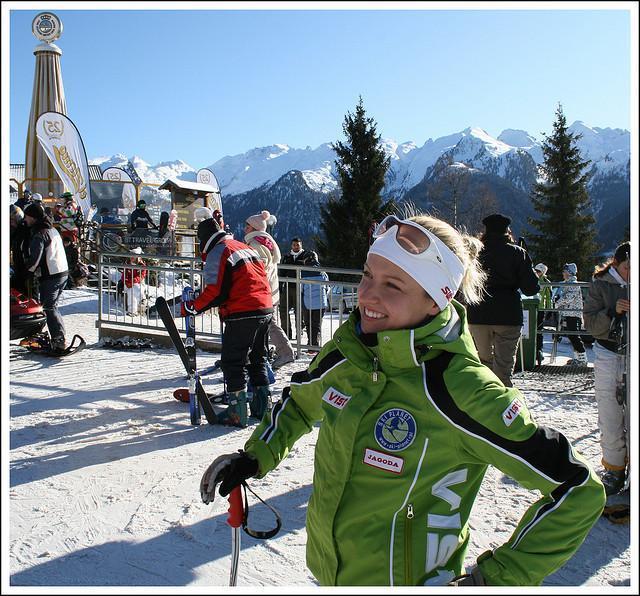How many people can be seen?
Give a very brief answer. 8. How many white toilets with brown lids are in this image?
Give a very brief answer. 0. 